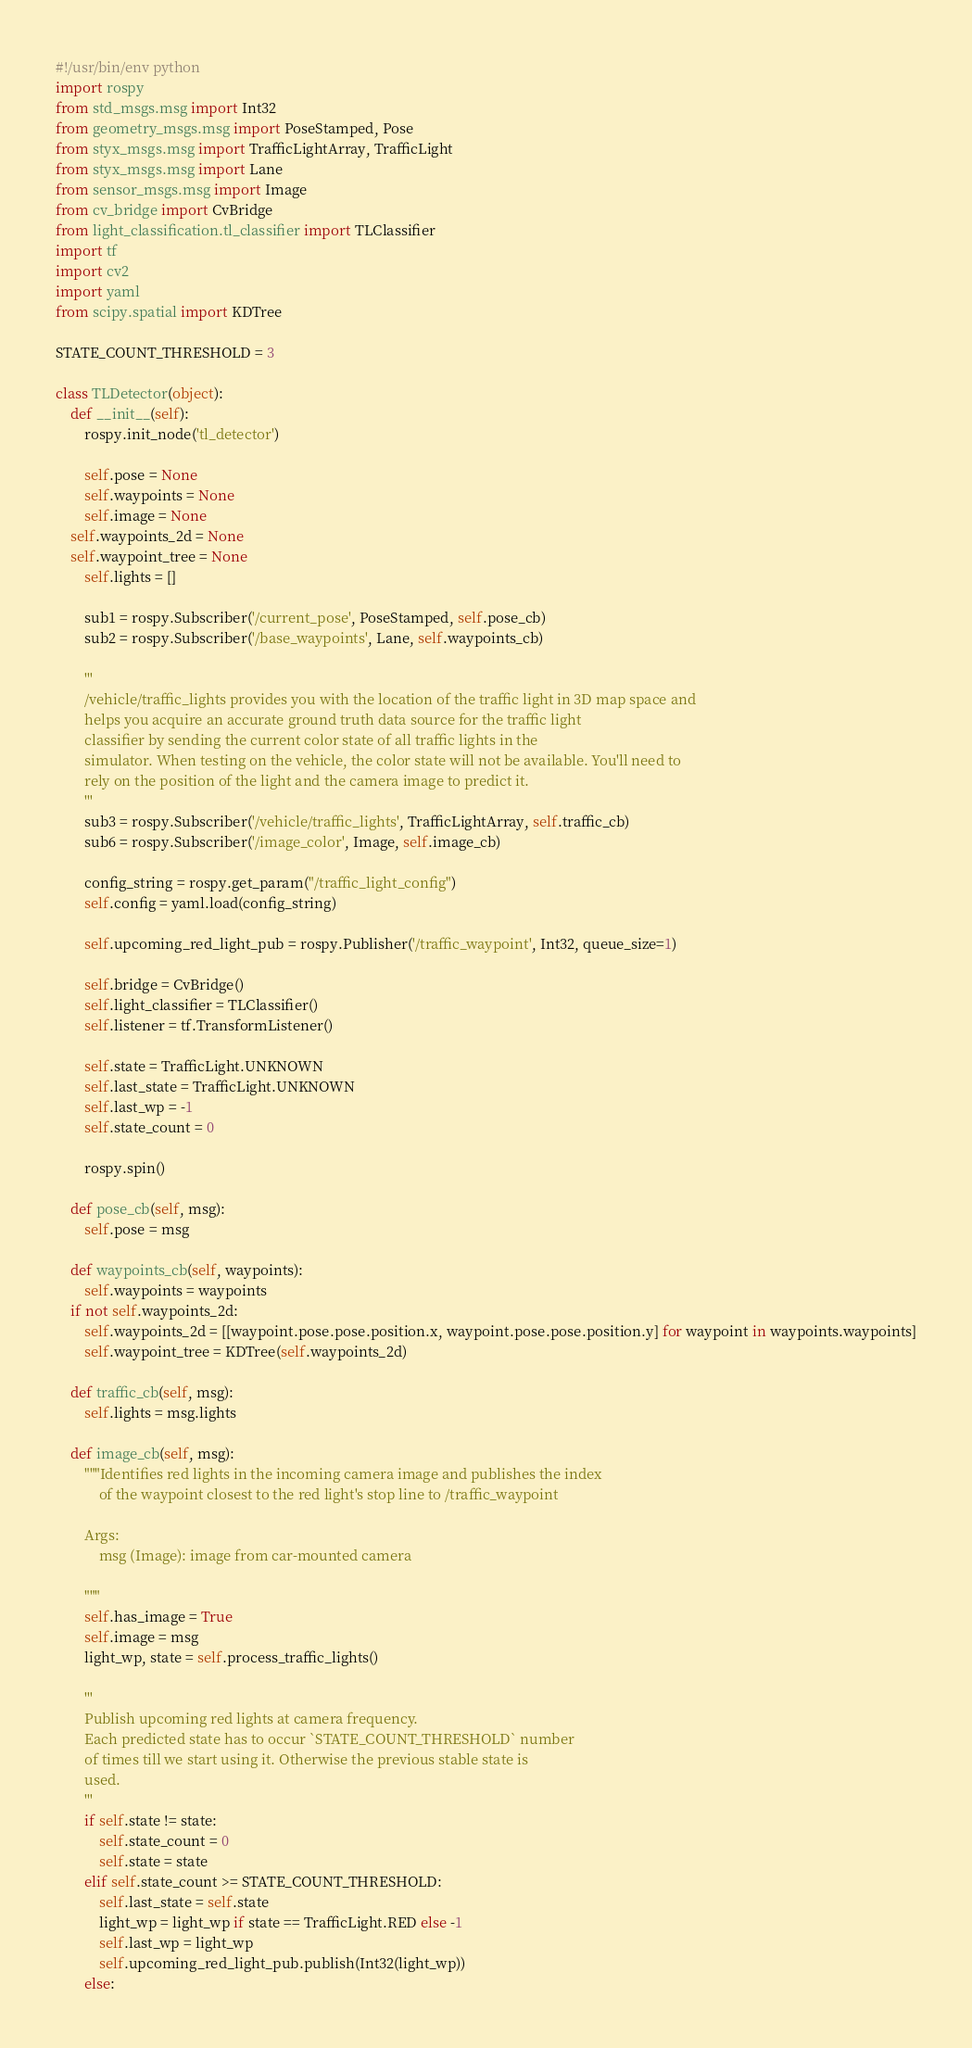<code> <loc_0><loc_0><loc_500><loc_500><_Python_>#!/usr/bin/env python
import rospy
from std_msgs.msg import Int32
from geometry_msgs.msg import PoseStamped, Pose
from styx_msgs.msg import TrafficLightArray, TrafficLight
from styx_msgs.msg import Lane
from sensor_msgs.msg import Image
from cv_bridge import CvBridge
from light_classification.tl_classifier import TLClassifier
import tf
import cv2
import yaml
from scipy.spatial import KDTree

STATE_COUNT_THRESHOLD = 3

class TLDetector(object):
    def __init__(self):
        rospy.init_node('tl_detector')

        self.pose = None
        self.waypoints = None
        self.image = None
	self.waypoints_2d = None
	self.waypoint_tree = None
        self.lights = []

        sub1 = rospy.Subscriber('/current_pose', PoseStamped, self.pose_cb)
        sub2 = rospy.Subscriber('/base_waypoints', Lane, self.waypoints_cb)

        '''
        /vehicle/traffic_lights provides you with the location of the traffic light in 3D map space and
        helps you acquire an accurate ground truth data source for the traffic light
        classifier by sending the current color state of all traffic lights in the
        simulator. When testing on the vehicle, the color state will not be available. You'll need to
        rely on the position of the light and the camera image to predict it.
        '''
        sub3 = rospy.Subscriber('/vehicle/traffic_lights', TrafficLightArray, self.traffic_cb)
        sub6 = rospy.Subscriber('/image_color', Image, self.image_cb)

        config_string = rospy.get_param("/traffic_light_config")
        self.config = yaml.load(config_string)

        self.upcoming_red_light_pub = rospy.Publisher('/traffic_waypoint', Int32, queue_size=1)

        self.bridge = CvBridge()
        self.light_classifier = TLClassifier()
        self.listener = tf.TransformListener()

        self.state = TrafficLight.UNKNOWN
        self.last_state = TrafficLight.UNKNOWN
        self.last_wp = -1
        self.state_count = 0

        rospy.spin()

    def pose_cb(self, msg):
        self.pose = msg

    def waypoints_cb(self, waypoints):
        self.waypoints = waypoints
	if not self.waypoints_2d:
		self.waypoints_2d = [[waypoint.pose.pose.position.x, waypoint.pose.pose.position.y] for waypoint in waypoints.waypoints]
		self.waypoint_tree = KDTree(self.waypoints_2d)

    def traffic_cb(self, msg):
        self.lights = msg.lights

    def image_cb(self, msg):
        """Identifies red lights in the incoming camera image and publishes the index
            of the waypoint closest to the red light's stop line to /traffic_waypoint

        Args:
            msg (Image): image from car-mounted camera

        """
        self.has_image = True
        self.image = msg
        light_wp, state = self.process_traffic_lights()

        '''
        Publish upcoming red lights at camera frequency.
        Each predicted state has to occur `STATE_COUNT_THRESHOLD` number
        of times till we start using it. Otherwise the previous stable state is
        used.
        '''
        if self.state != state:
            self.state_count = 0
            self.state = state
        elif self.state_count >= STATE_COUNT_THRESHOLD:
            self.last_state = self.state
            light_wp = light_wp if state == TrafficLight.RED else -1
            self.last_wp = light_wp
            self.upcoming_red_light_pub.publish(Int32(light_wp))
        else:</code> 